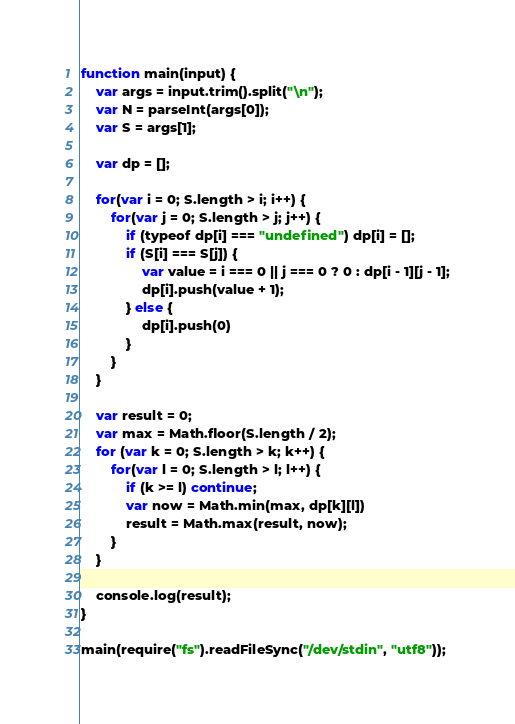Convert code to text. <code><loc_0><loc_0><loc_500><loc_500><_JavaScript_>function main(input) {
    var args = input.trim().split("\n");
    var N = parseInt(args[0]);
    var S = args[1];

    var dp = [];

    for(var i = 0; S.length > i; i++) {
        for(var j = 0; S.length > j; j++) {
            if (typeof dp[i] === "undefined") dp[i] = [];
            if (S[i] === S[j]) {
                var value = i === 0 || j === 0 ? 0 : dp[i - 1][j - 1];
                dp[i].push(value + 1);
            } else {
                dp[i].push(0)
            }
        }
    }

    var result = 0;
    var max = Math.floor(S.length / 2);
    for (var k = 0; S.length > k; k++) {
        for(var l = 0; S.length > l; l++) {
            if (k >= l) continue;
            var now = Math.min(max, dp[k][l])
            result = Math.max(result, now);
        }
    }

    console.log(result);
}

main(require("fs").readFileSync("/dev/stdin", "utf8"));</code> 